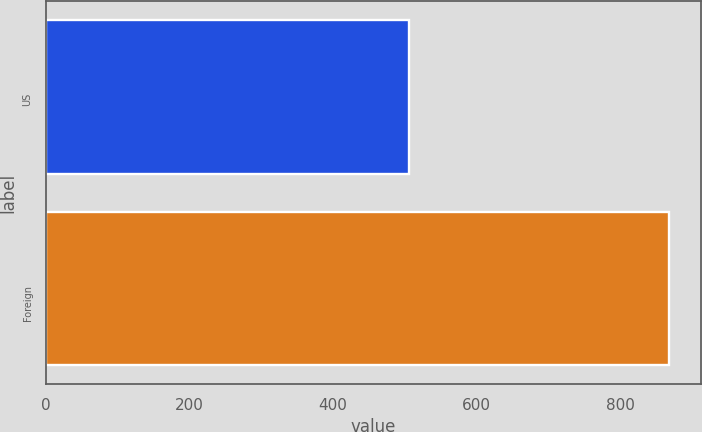Convert chart to OTSL. <chart><loc_0><loc_0><loc_500><loc_500><bar_chart><fcel>US<fcel>Foreign<nl><fcel>506<fcel>868<nl></chart> 